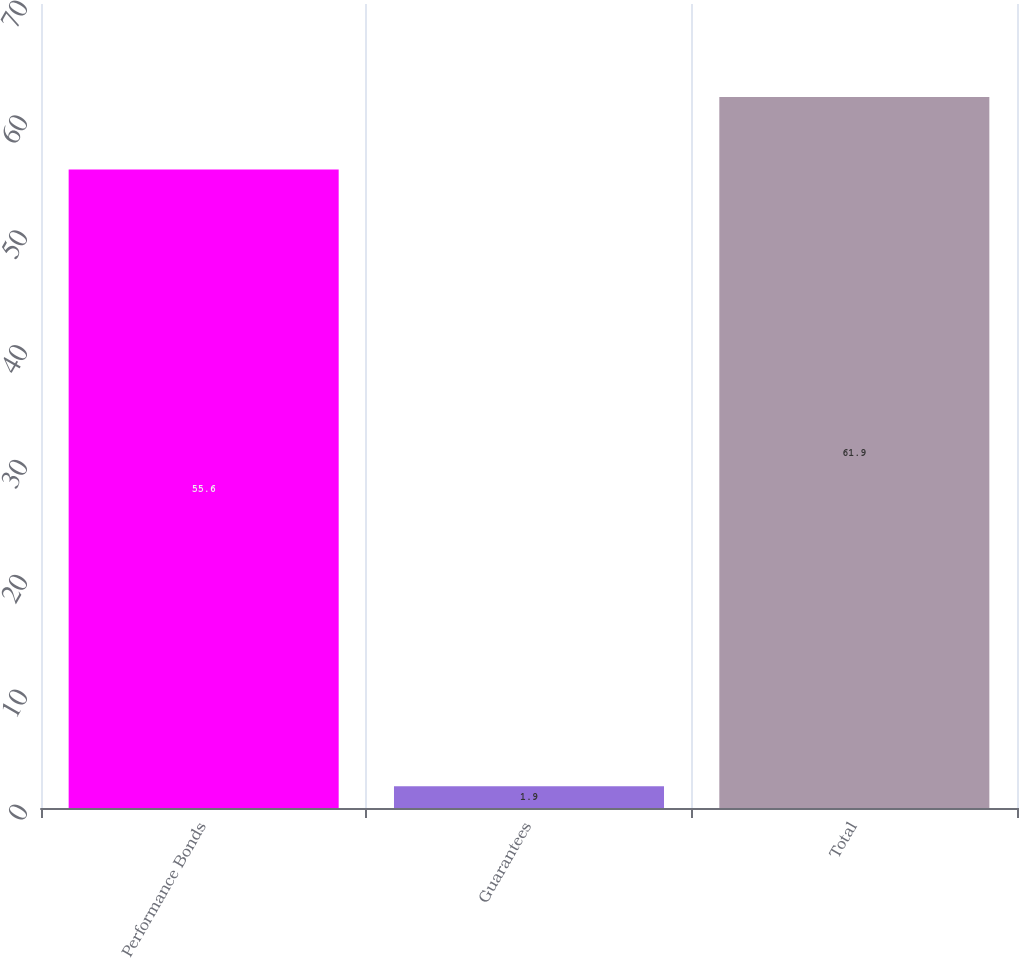Convert chart. <chart><loc_0><loc_0><loc_500><loc_500><bar_chart><fcel>Performance Bonds<fcel>Guarantees<fcel>Total<nl><fcel>55.6<fcel>1.9<fcel>61.9<nl></chart> 